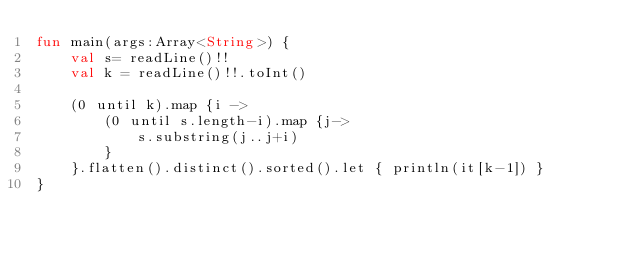Convert code to text. <code><loc_0><loc_0><loc_500><loc_500><_Kotlin_>fun main(args:Array<String>) {
	val s= readLine()!!
	val k = readLine()!!.toInt()
	
	(0 until k).map {i ->
		(0 until s.length-i).map {j->
			s.substring(j..j+i)
		}
	}.flatten().distinct().sorted().let { println(it[k-1]) }
}</code> 